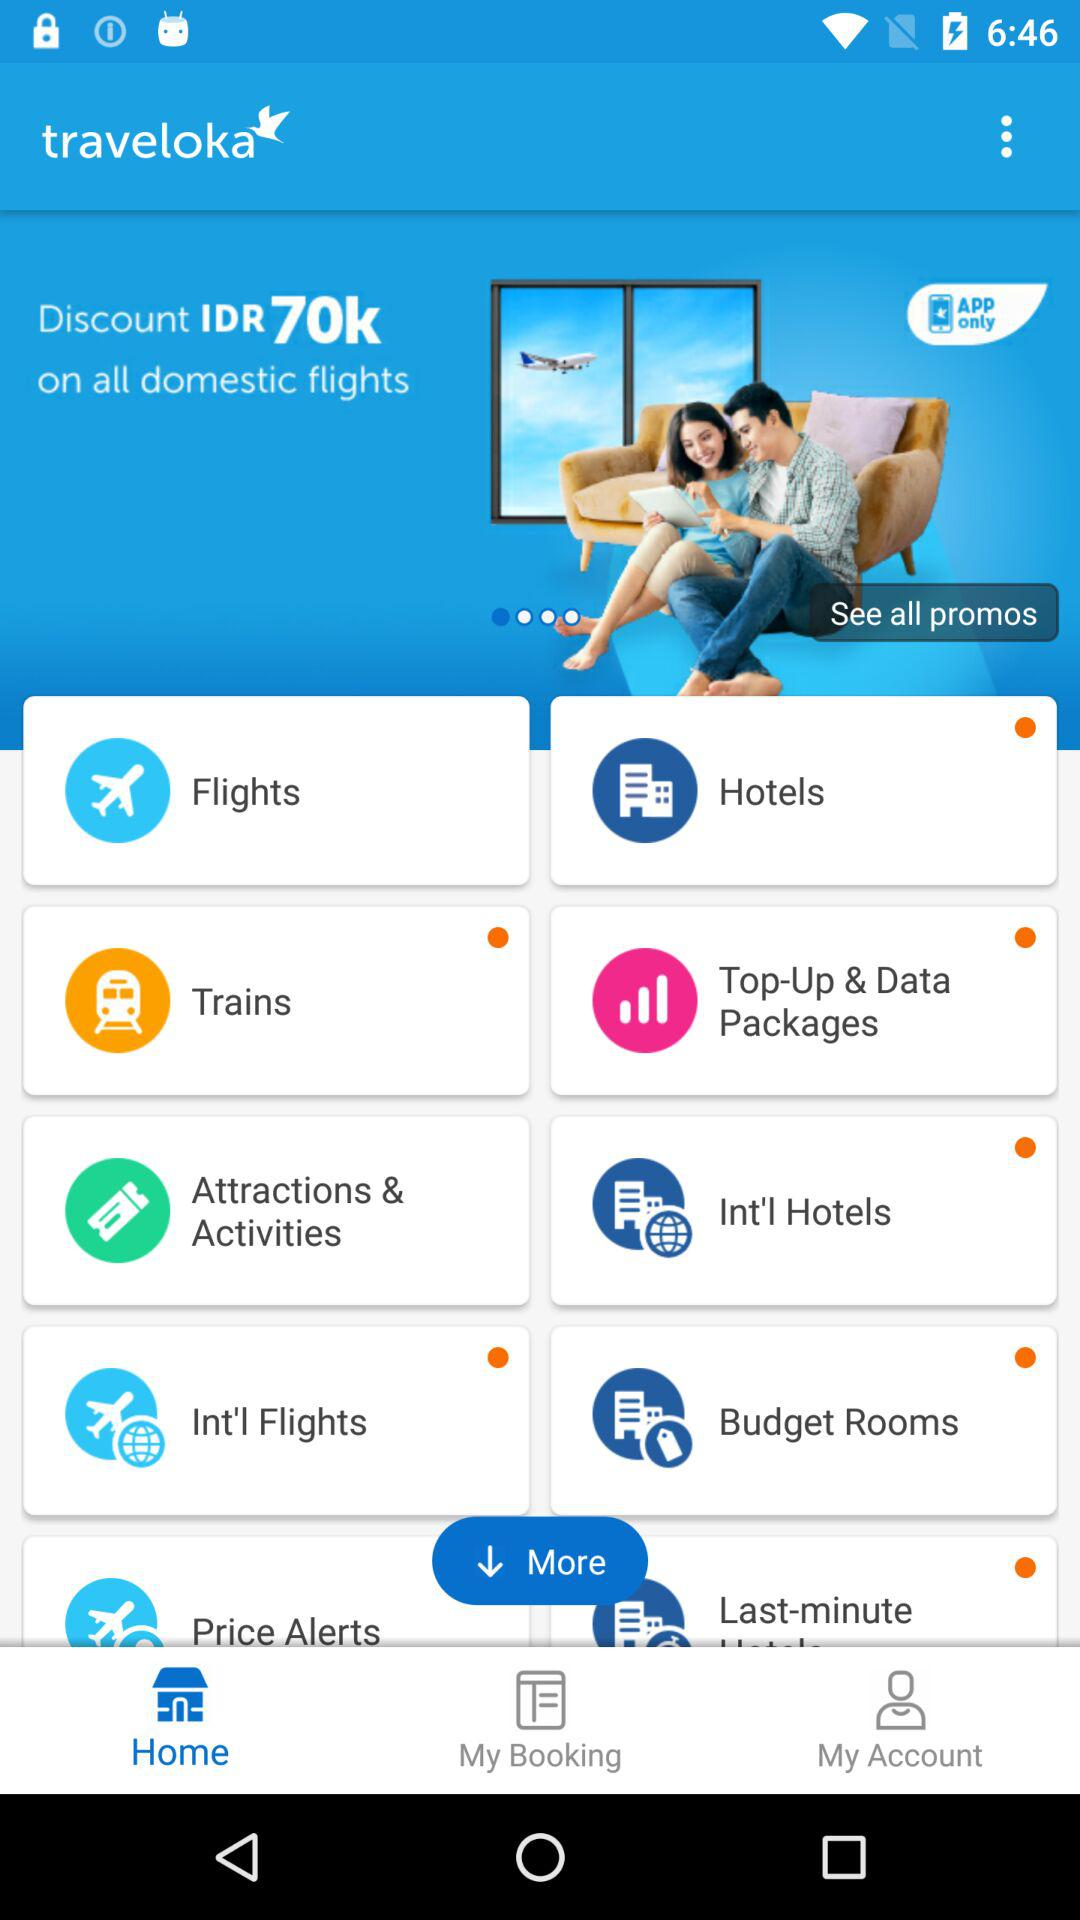What is the selected tab? The selected tab is Home. 